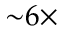<formula> <loc_0><loc_0><loc_500><loc_500>{ \sim } 6 \times</formula> 